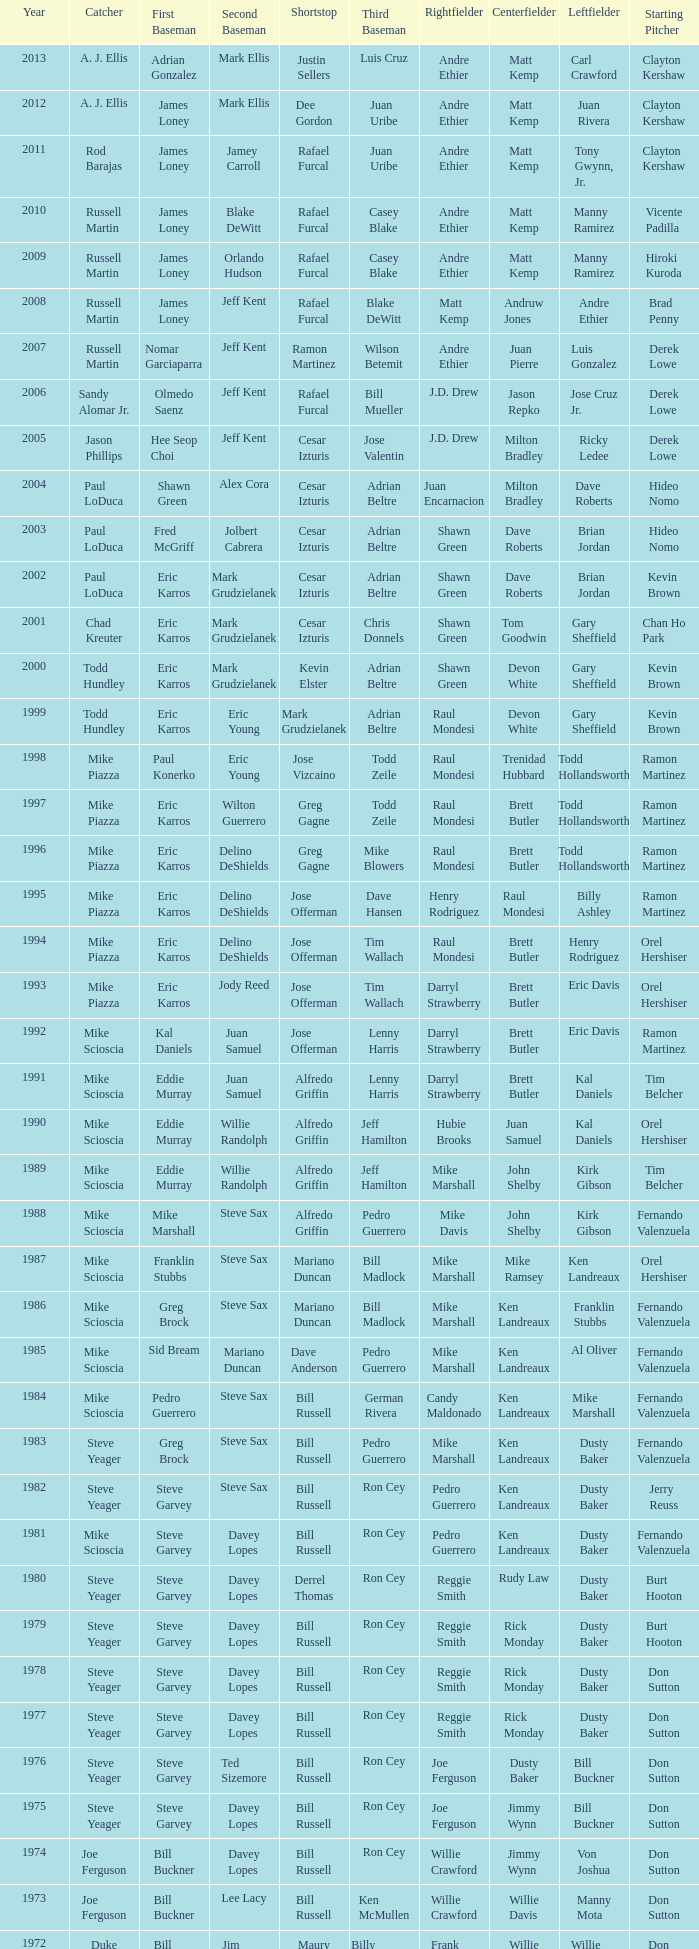Who was the RF when the SP was vicente padilla? Andre Ethier. 